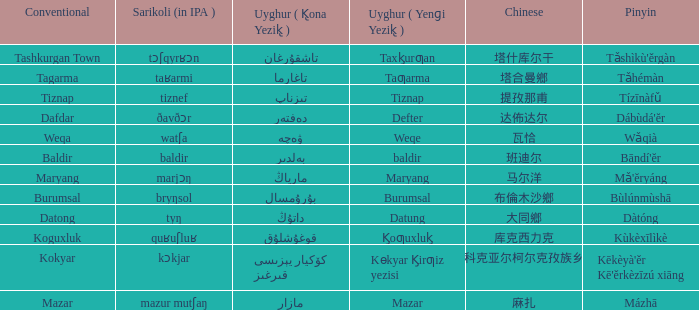Name the pinyin for mazar Mázhā. 